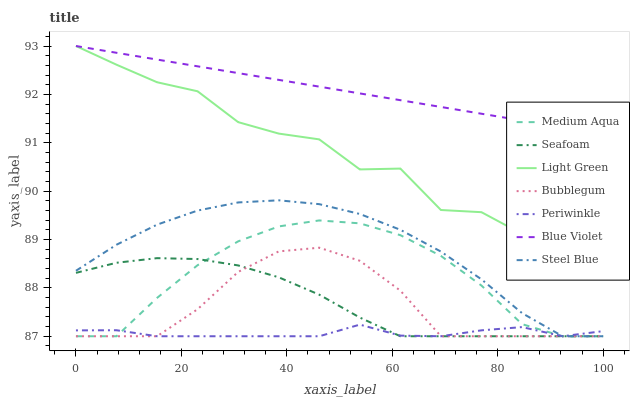Does Periwinkle have the minimum area under the curve?
Answer yes or no. Yes. Does Blue Violet have the maximum area under the curve?
Answer yes or no. Yes. Does Bubblegum have the minimum area under the curve?
Answer yes or no. No. Does Bubblegum have the maximum area under the curve?
Answer yes or no. No. Is Blue Violet the smoothest?
Answer yes or no. Yes. Is Light Green the roughest?
Answer yes or no. Yes. Is Bubblegum the smoothest?
Answer yes or no. No. Is Bubblegum the roughest?
Answer yes or no. No. Does Seafoam have the lowest value?
Answer yes or no. Yes. Does Light Green have the lowest value?
Answer yes or no. No. Does Blue Violet have the highest value?
Answer yes or no. Yes. Does Bubblegum have the highest value?
Answer yes or no. No. Is Bubblegum less than Blue Violet?
Answer yes or no. Yes. Is Blue Violet greater than Periwinkle?
Answer yes or no. Yes. Does Medium Aqua intersect Bubblegum?
Answer yes or no. Yes. Is Medium Aqua less than Bubblegum?
Answer yes or no. No. Is Medium Aqua greater than Bubblegum?
Answer yes or no. No. Does Bubblegum intersect Blue Violet?
Answer yes or no. No. 